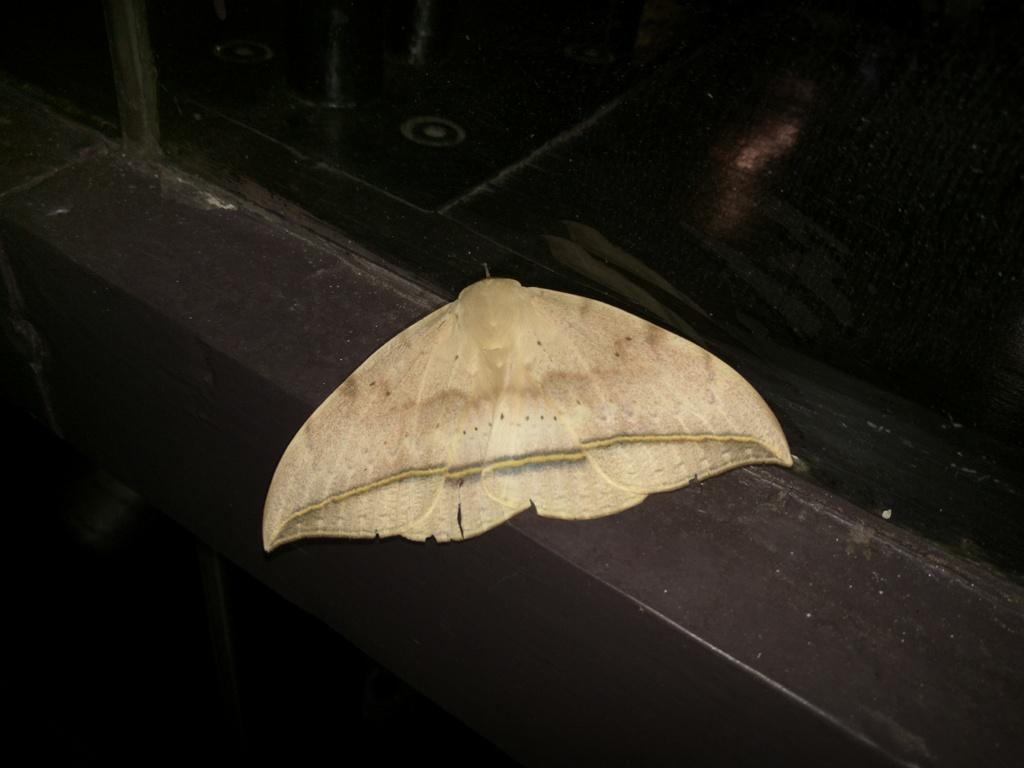What is the main subject of the image? The main subject of the image is a moth. Where is the moth located in the image? The moth is in the middle of the image. What can be observed about the background of the image? The background of the image is dark. What type of basketball game is being played in the image? There is no basketball game present in the image; it features a moth in a dark background. 